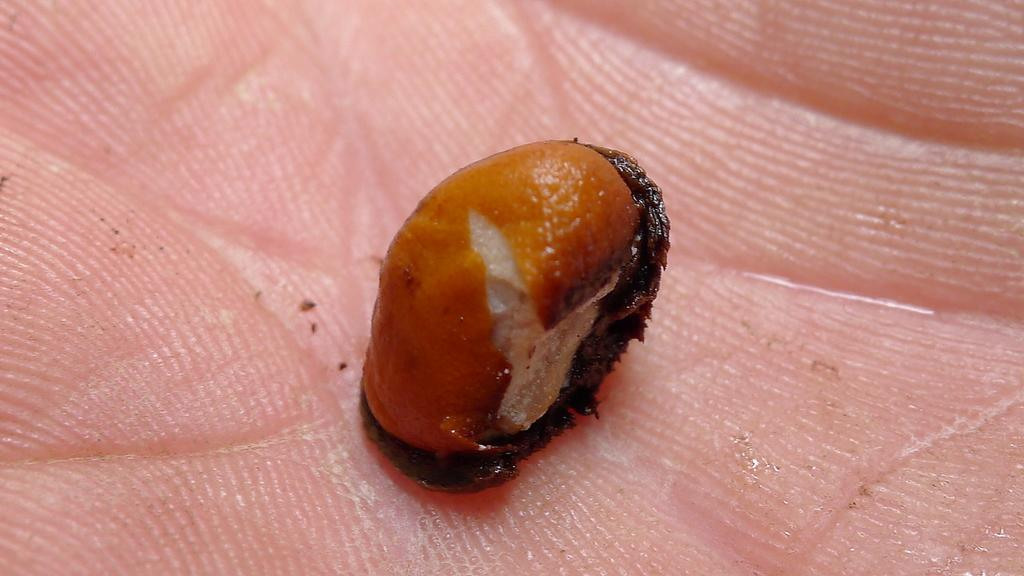What is being depicted in the image? There are food items visible in the image. Who or what is holding the food items? The food items are being held by someone. What type of operation is being performed on the page in the image? There is no page or operation present in the image; it features food items being held by someone. 